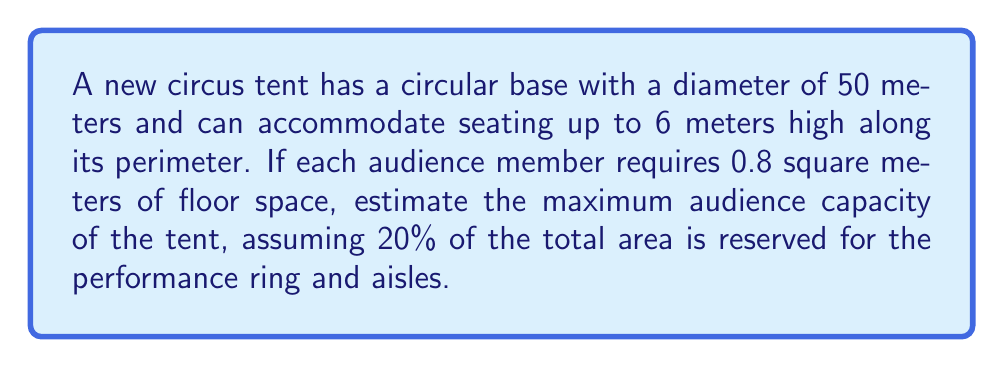Can you solve this math problem? Let's approach this step-by-step:

1) First, calculate the total floor area of the tent:
   Area = $\pi r^2 = \pi (25\text{ m})^2 = 1963.5\text{ m}^2$

2) Subtract 20% for the performance ring and aisles:
   Available seating area = $80\% \times 1963.5\text{ m}^2 = 1570.8\text{ m}^2$

3) Calculate the number of people that can fit in this area:
   Number of people = $\frac{\text{Available area}}{\text{Area per person}} = \frac{1570.8\text{ m}^2}{0.8\text{ m}^2/\text{person}} = 1963.5\text{ people}$

4) Round down to the nearest whole number:
   Estimated capacity = 1963 people

This estimation assumes a single level of seating. In reality, the 6-meter height allowance might permit tiered seating, potentially increasing capacity. However, without more specific information about the seating arrangement, this basic calculation provides a reasonable estimate for a talent agent to consider when booking acts.
Answer: 1963 people 